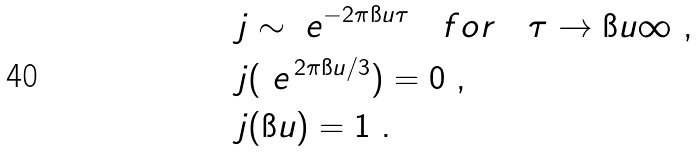Convert formula to latex. <formula><loc_0><loc_0><loc_500><loc_500>& j \sim \ e ^ { - 2 \pi \i u \tau } \quad f o r \quad \tau \to \i u \infty \ , \\ & j ( \ e ^ { \, 2 \pi \i u / 3 } ) = 0 \ , \\ & j ( \i u ) = 1 \ .</formula> 